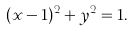<formula> <loc_0><loc_0><loc_500><loc_500>( x - 1 ) ^ { 2 } + y ^ { 2 } = 1 .</formula> 